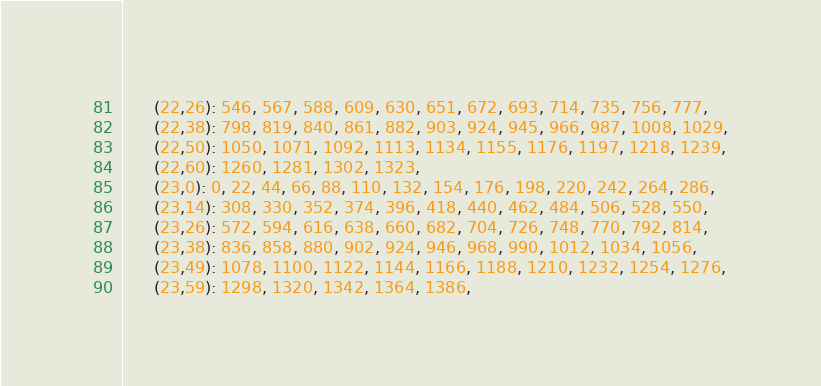Convert code to text. <code><loc_0><loc_0><loc_500><loc_500><_SQL_>      (22,26): 546, 567, 588, 609, 630, 651, 672, 693, 714, 735, 756, 777,
      (22,38): 798, 819, 840, 861, 882, 903, 924, 945, 966, 987, 1008, 1029,
      (22,50): 1050, 1071, 1092, 1113, 1134, 1155, 1176, 1197, 1218, 1239,
      (22,60): 1260, 1281, 1302, 1323,
      (23,0): 0, 22, 44, 66, 88, 110, 132, 154, 176, 198, 220, 242, 264, 286,
      (23,14): 308, 330, 352, 374, 396, 418, 440, 462, 484, 506, 528, 550,
      (23,26): 572, 594, 616, 638, 660, 682, 704, 726, 748, 770, 792, 814,
      (23,38): 836, 858, 880, 902, 924, 946, 968, 990, 1012, 1034, 1056,
      (23,49): 1078, 1100, 1122, 1144, 1166, 1188, 1210, 1232, 1254, 1276,
      (23,59): 1298, 1320, 1342, 1364, 1386,</code> 